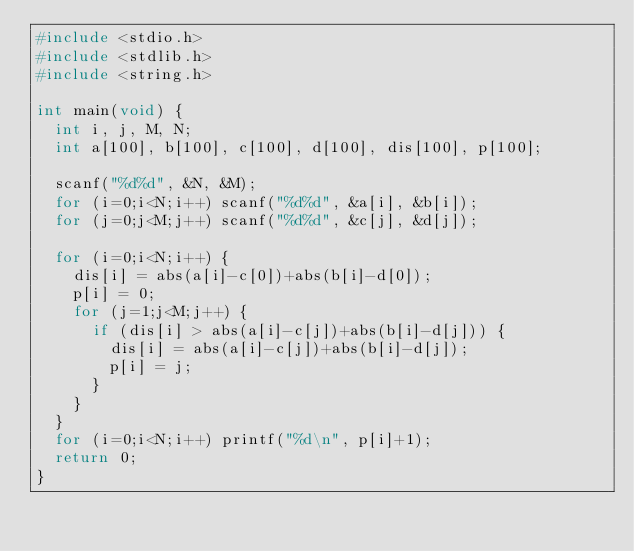<code> <loc_0><loc_0><loc_500><loc_500><_C_>#include <stdio.h>
#include <stdlib.h>
#include <string.h>

int main(void) {
	int i, j, M, N;
	int a[100], b[100], c[100], d[100], dis[100], p[100];

	scanf("%d%d", &N, &M);
	for (i=0;i<N;i++) scanf("%d%d", &a[i], &b[i]);
	for (j=0;j<M;j++) scanf("%d%d", &c[j], &d[j]);

	for (i=0;i<N;i++) {
		dis[i] = abs(a[i]-c[0])+abs(b[i]-d[0]);
		p[i] = 0;
		for (j=1;j<M;j++) {
			if (dis[i] > abs(a[i]-c[j])+abs(b[i]-d[j])) {
				dis[i] = abs(a[i]-c[j])+abs(b[i]-d[j]);
				p[i] = j;
			}
		}
	}
	for (i=0;i<N;i++) printf("%d\n", p[i]+1);
	return 0;
}</code> 